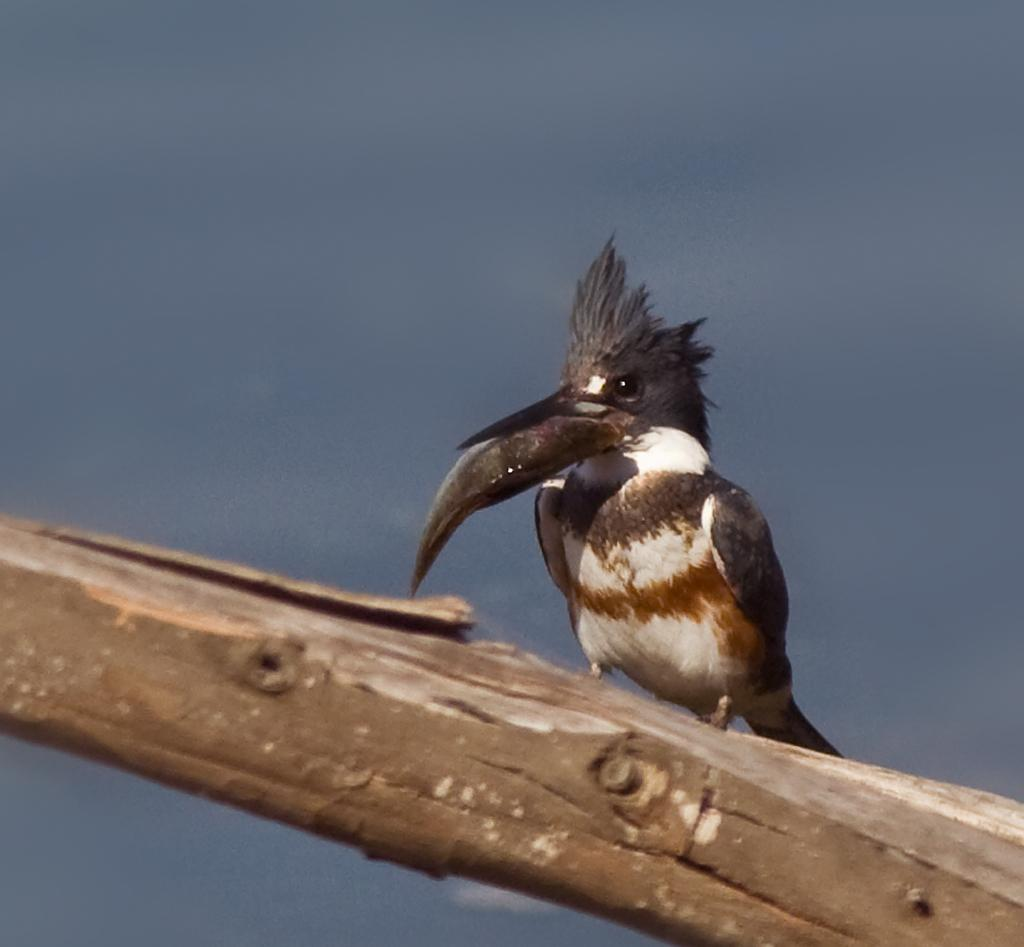What type of animal can be seen in the image? There is a bird in the image. Where is the bird located in the image? The bird is sitting on a branch. What colors can be seen on the bird? The bird has white, brown, and black colors. What is visible in the background of the image? There is a blue sky visible in the background of the image. Can you touch the bird in the image? No, you cannot touch the bird in the image, as it is a two-dimensional representation and not a real, physical bird. 